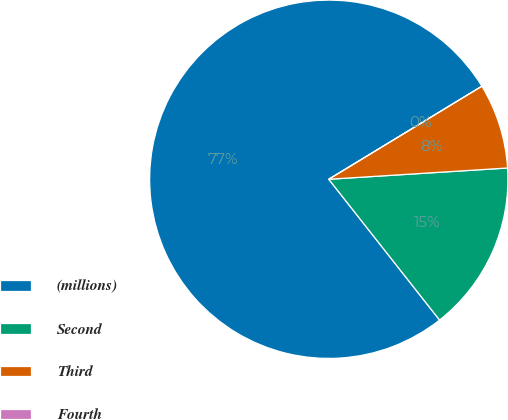Convert chart to OTSL. <chart><loc_0><loc_0><loc_500><loc_500><pie_chart><fcel>(millions)<fcel>Second<fcel>Third<fcel>Fourth<nl><fcel>76.92%<fcel>15.39%<fcel>7.69%<fcel>0.0%<nl></chart> 